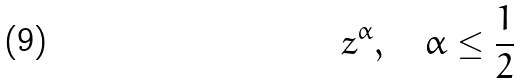Convert formula to latex. <formula><loc_0><loc_0><loc_500><loc_500>z ^ { \alpha } , \quad \alpha \leq \frac { 1 } { 2 }</formula> 